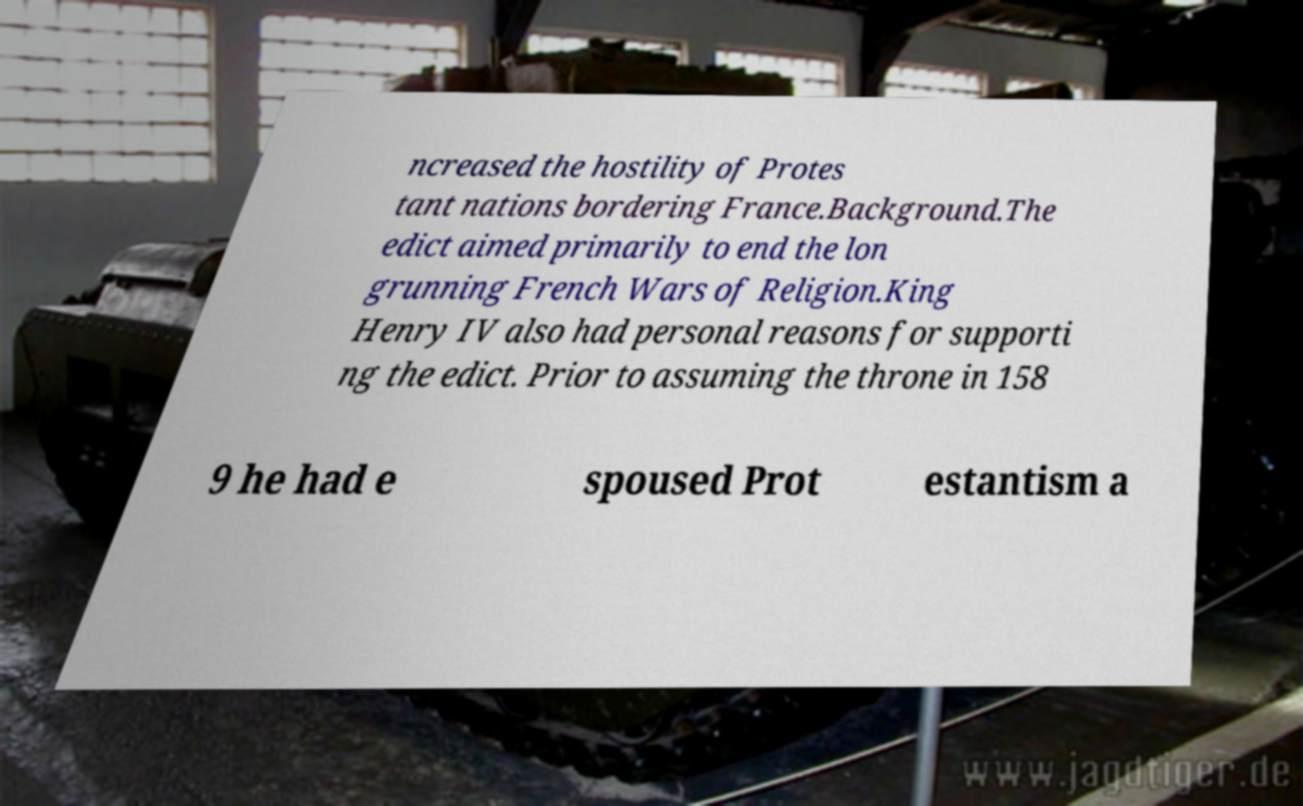Please identify and transcribe the text found in this image. ncreased the hostility of Protes tant nations bordering France.Background.The edict aimed primarily to end the lon grunning French Wars of Religion.King Henry IV also had personal reasons for supporti ng the edict. Prior to assuming the throne in 158 9 he had e spoused Prot estantism a 